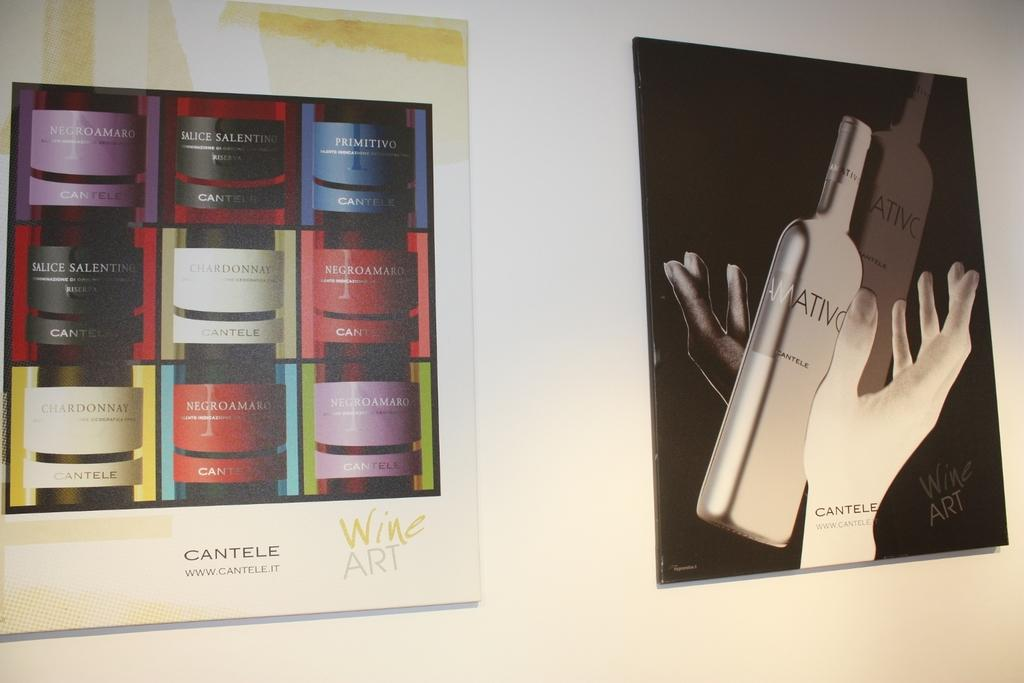Provide a one-sentence caption for the provided image. Two picture of wine bottles, one of which is labelled cantele. 